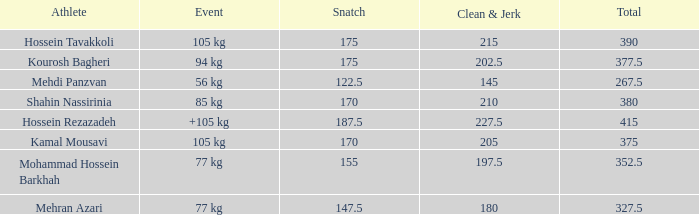How many snatches had a combined sum of 26 0.0. 